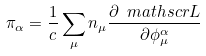<formula> <loc_0><loc_0><loc_500><loc_500>\pi _ { \alpha } = \frac { 1 } { c } \sum _ { \mu } n _ { \mu } \frac { \partial \ m a t h s c r { L } } { \partial \phi _ { \mu } ^ { \alpha } }</formula> 